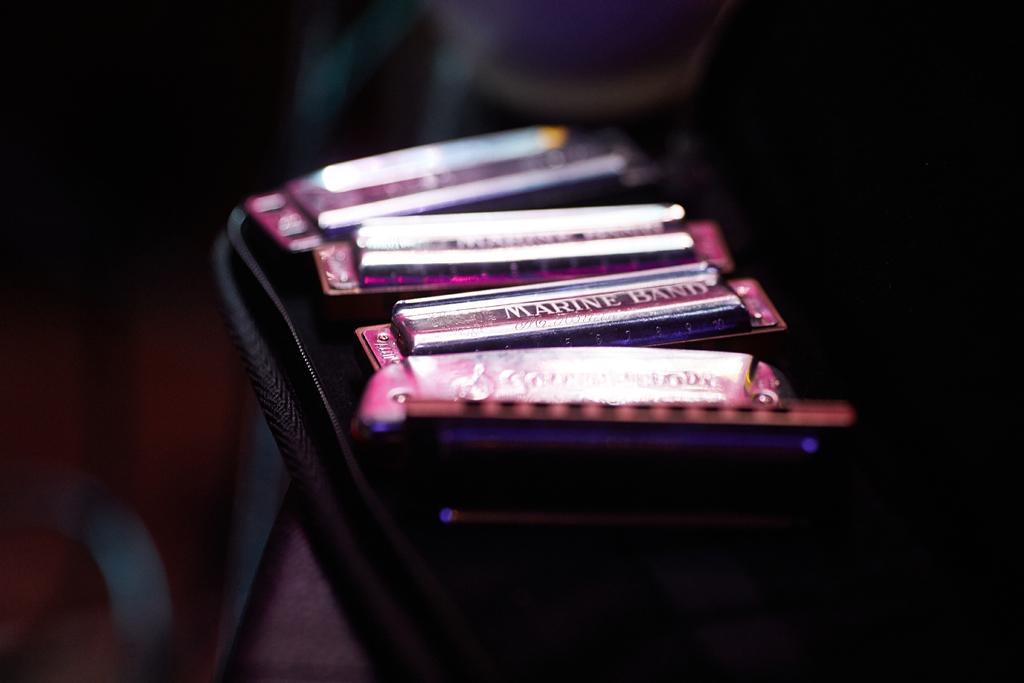Could you give a brief overview of what you see in this image? In this picture I can see there are few pink color objects placed in a black case and the backdrop is dark. 